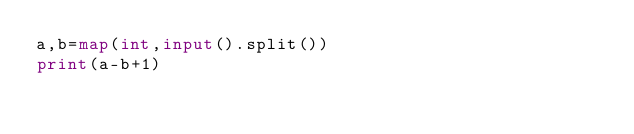Convert code to text. <code><loc_0><loc_0><loc_500><loc_500><_Python_>a,b=map(int,input().split())
print(a-b+1)</code> 